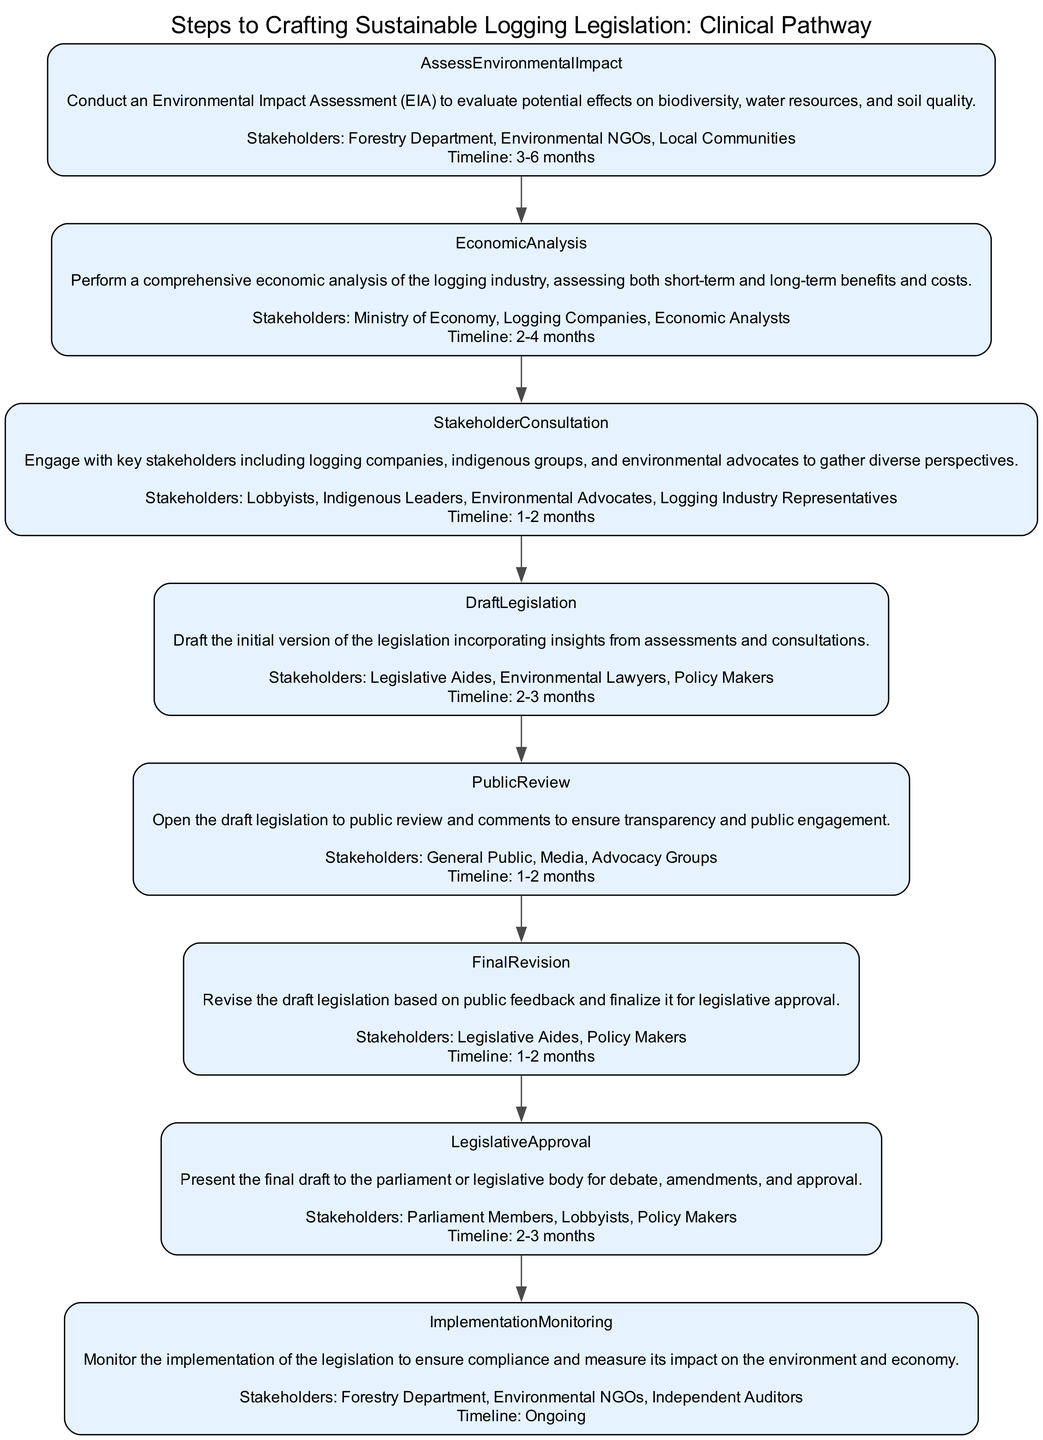What is the first step in the diagram? The first step listed in the diagram is "Assess Environmental Impact." It is the first node in the sequence of steps.
Answer: Assess Environmental Impact How many stakeholders are involved in the "Draft Legislation" step? The "Draft Legislation" step has three stakeholders: Legislative Aides, Environmental Lawyers, and Policy Makers. By counting them, we find there are three.
Answer: 3 What is the timeline for "Economic Analysis"? The timeline indicated for "Economic Analysis" is 2-4 months. This specific detail is mentioned directly in the description of that step.
Answer: 2-4 months Which steps involve the "Lobbyists"? The "Stakeholder Consultation" step and the "Legislative Approval" step both mention "Lobbyists" as stakeholders. Thus, these are the two instances where Lobbyists are involved.
Answer: Stakeholder Consultation, Legislative Approval Which step comes after "Public Review"? The step that comes after "Public Review" is "Final Revision." By following the arrows in the diagram, we see the direct connection from Public Review to Final Revision.
Answer: Final Revision How many steps are there in total? By counting all the nodes in the given diagram, there are eight steps outlined in the pathway. This includes each of the individual processes listed.
Answer: 8 What is the last step in the clinical pathway? The last step in the clinical pathway is "Implementation Monitoring." It is the final node that indicates ongoing processes after legislation approval.
Answer: Implementation Monitoring What stakeholders are involved in "Implementation Monitoring"? The stakeholders listed for "Implementation Monitoring" are the Forestry Department, Environmental NGOs, and Independent Auditors. By examining this node, we identify these three groups.
Answer: Forestry Department, Environmental NGOs, Independent Auditors 